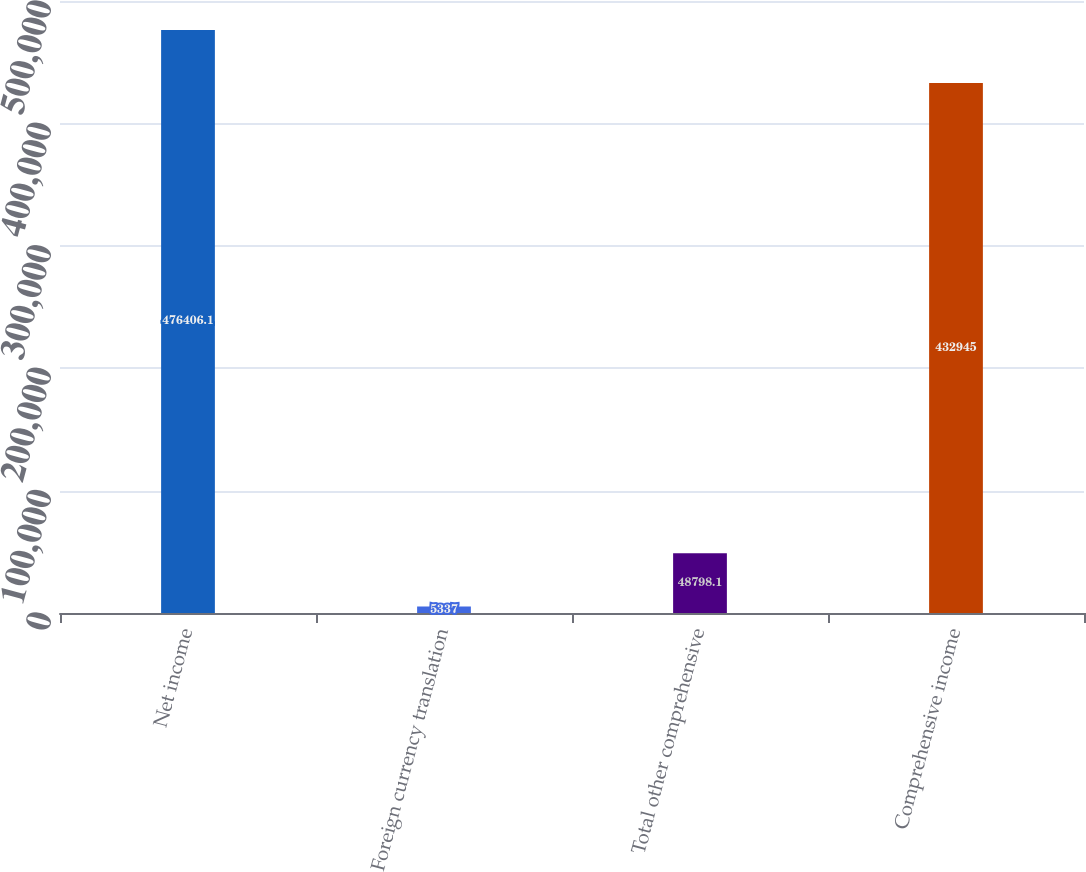<chart> <loc_0><loc_0><loc_500><loc_500><bar_chart><fcel>Net income<fcel>Foreign currency translation<fcel>Total other comprehensive<fcel>Comprehensive income<nl><fcel>476406<fcel>5337<fcel>48798.1<fcel>432945<nl></chart> 